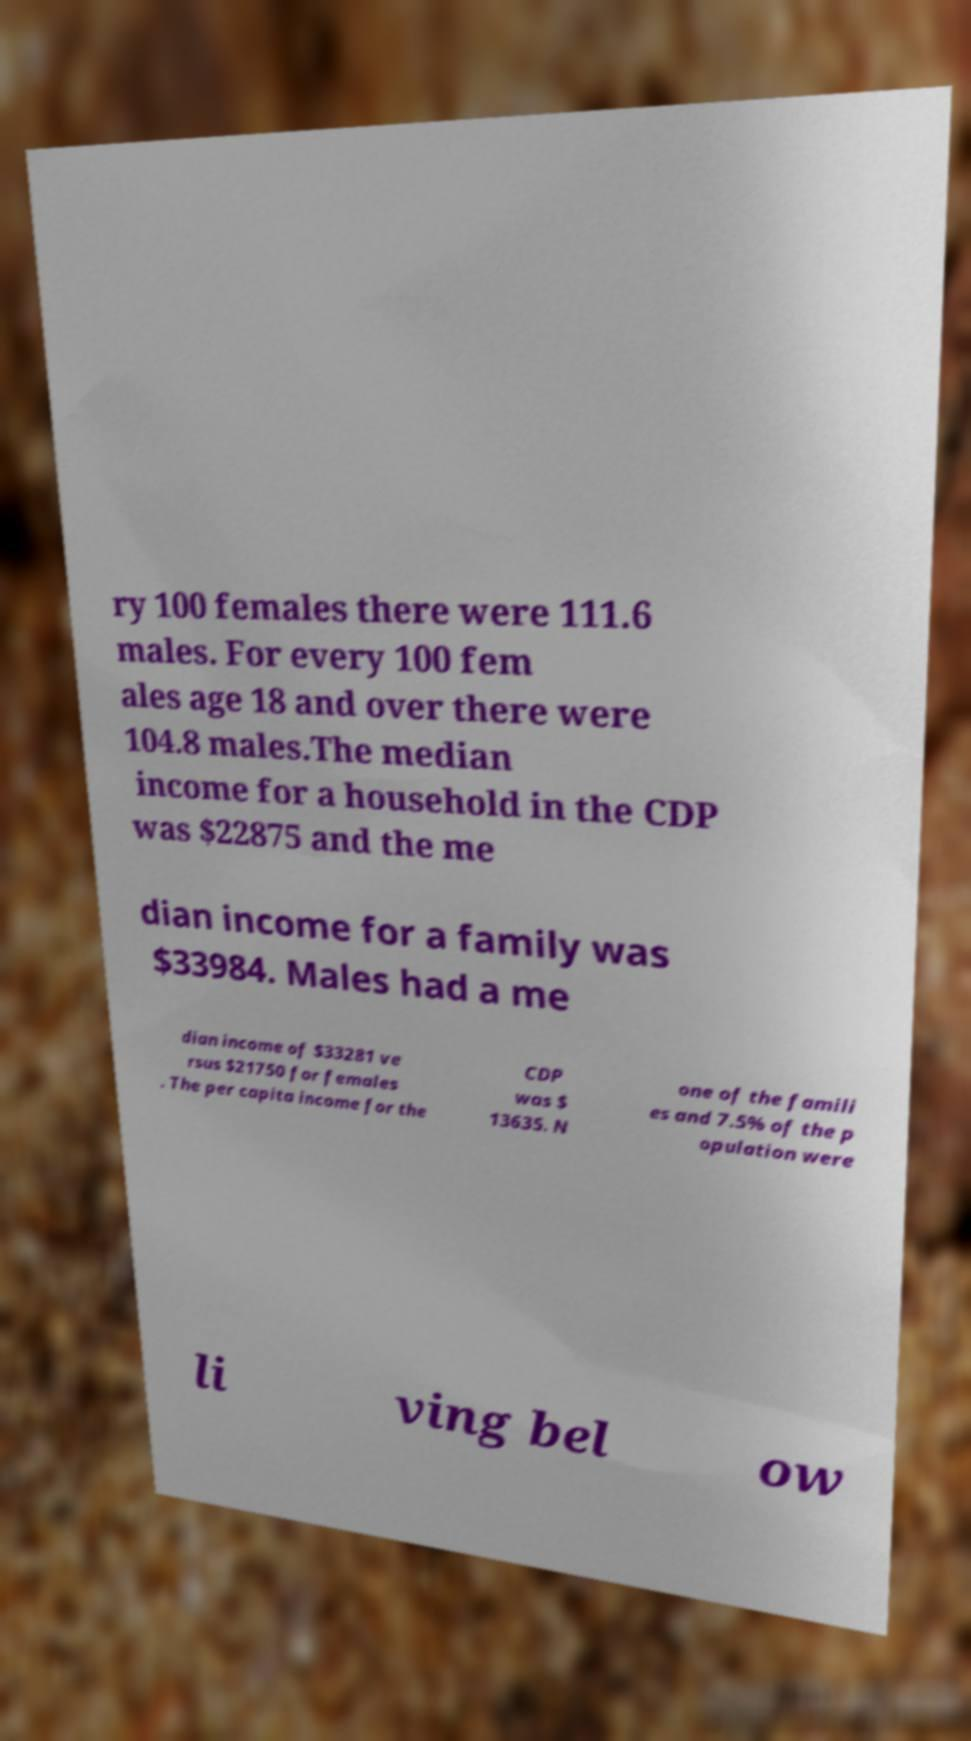I need the written content from this picture converted into text. Can you do that? ry 100 females there were 111.6 males. For every 100 fem ales age 18 and over there were 104.8 males.The median income for a household in the CDP was $22875 and the me dian income for a family was $33984. Males had a me dian income of $33281 ve rsus $21750 for females . The per capita income for the CDP was $ 13635. N one of the famili es and 7.5% of the p opulation were li ving bel ow 